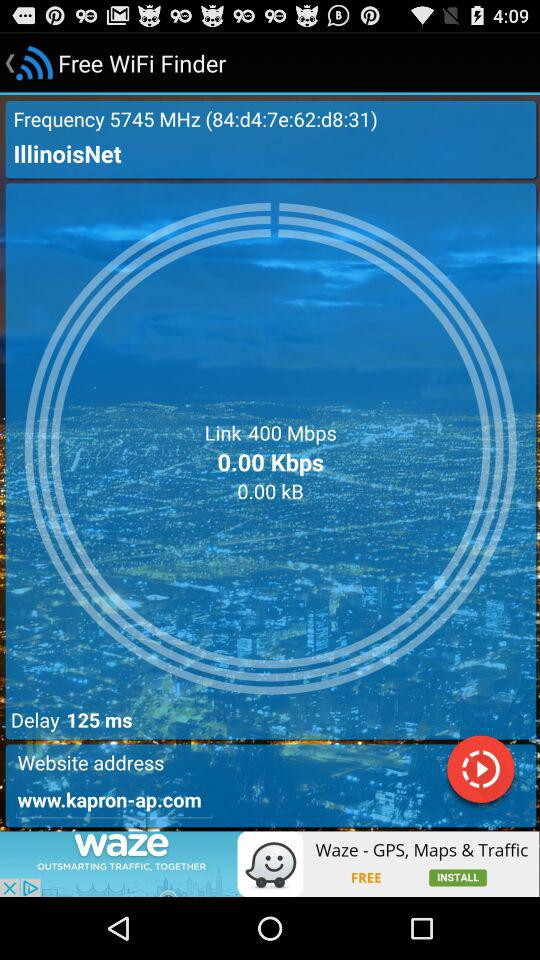What is the link speed of the network?
Answer the question using a single word or phrase. 400 Mbps 